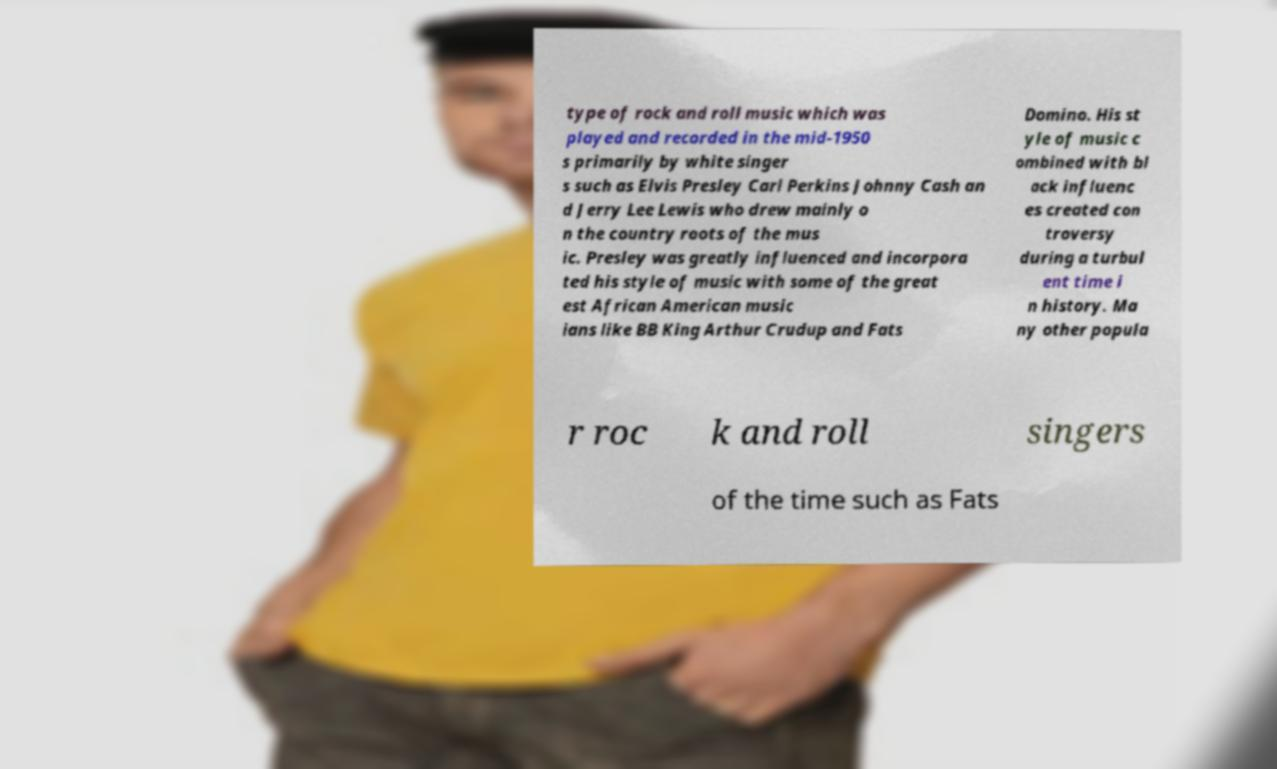For documentation purposes, I need the text within this image transcribed. Could you provide that? type of rock and roll music which was played and recorded in the mid-1950 s primarily by white singer s such as Elvis Presley Carl Perkins Johnny Cash an d Jerry Lee Lewis who drew mainly o n the country roots of the mus ic. Presley was greatly influenced and incorpora ted his style of music with some of the great est African American music ians like BB King Arthur Crudup and Fats Domino. His st yle of music c ombined with bl ack influenc es created con troversy during a turbul ent time i n history. Ma ny other popula r roc k and roll singers of the time such as Fats 